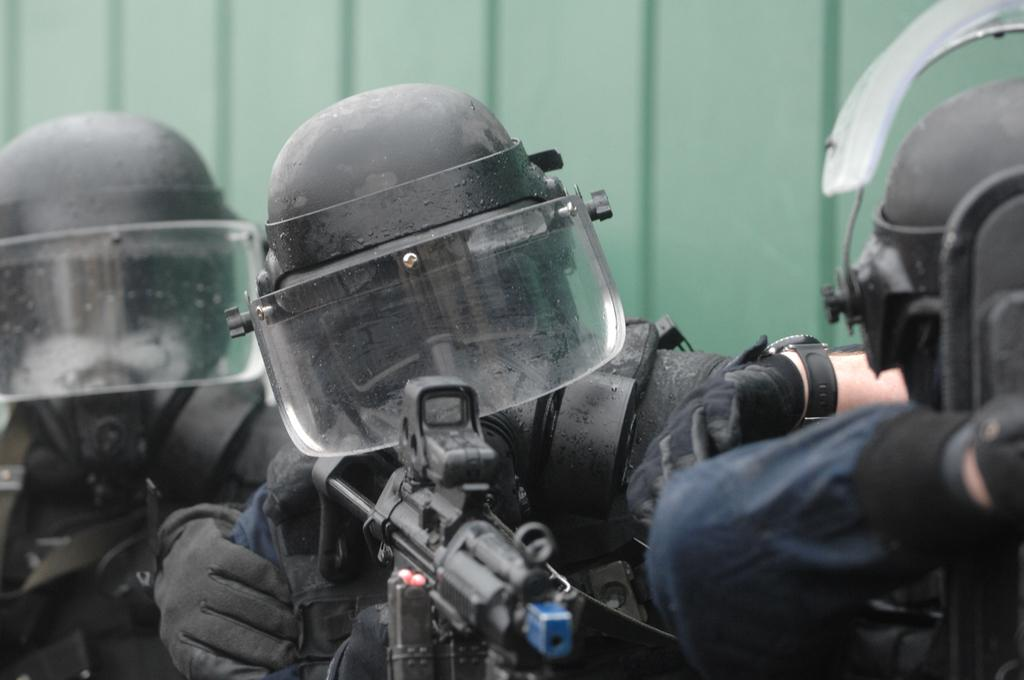What are the people in the image wearing on their heads? The people in the image are wearing helmets. What type of clothing are the people wearing in the image? The people are wearing uniforms in the image. Can you describe any specific accessories worn by the people? One person is wearing gloves. What is one person holding in the image? One person is holding a gun. What can be seen in the background of the image? There is a wall in the background of the image. How many rabbits are visible in the image? There are no rabbits present in the image. What type of skirt is the person wearing in the image? There is no skirt visible in the image; the people are wearing uniforms. 